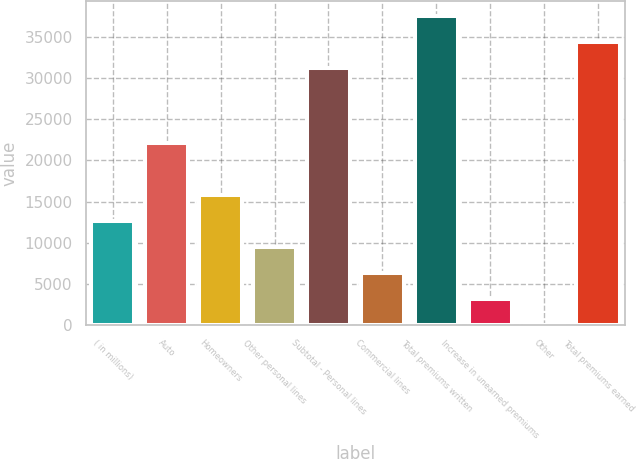Convert chart to OTSL. <chart><loc_0><loc_0><loc_500><loc_500><bar_chart><fcel>( in millions)<fcel>Auto<fcel>Homeowners<fcel>Other personal lines<fcel>Subtotal - Personal lines<fcel>Commercial lines<fcel>Total premiums written<fcel>Increase in unearned premiums<fcel>Other<fcel>Total premiums earned<nl><fcel>12685<fcel>22042<fcel>15845.5<fcel>9524.5<fcel>31160<fcel>6364<fcel>37481<fcel>3203.5<fcel>43<fcel>34320.5<nl></chart> 